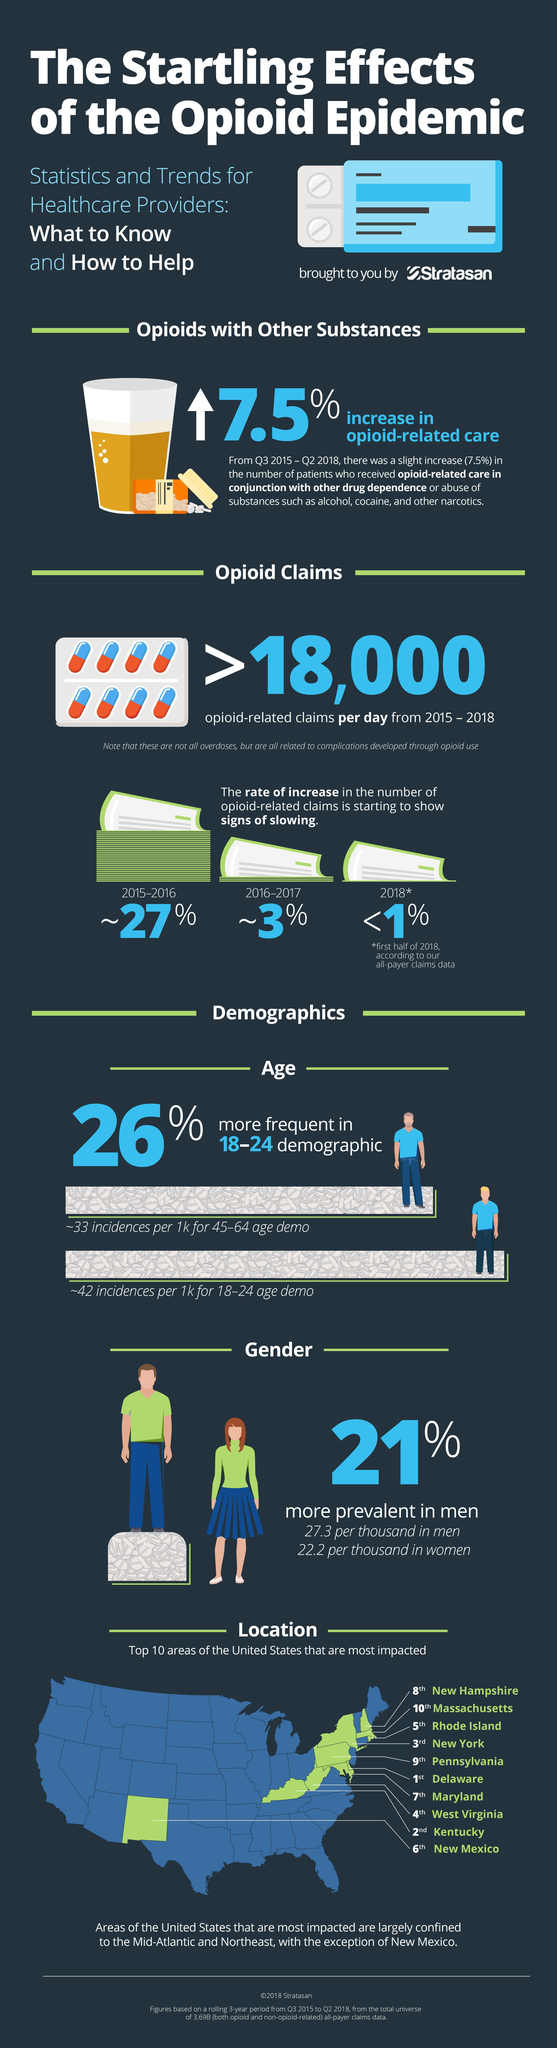Outline some significant characteristics in this image. In the age groups 18-24 and 45-64, there is a significant difference in incidence. In 2018, there were the lowest claims related to opioids. 